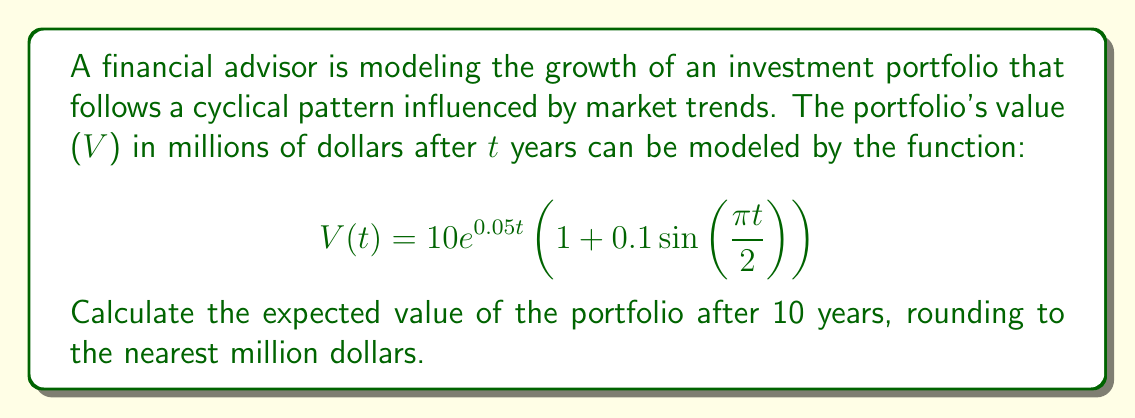Solve this math problem. Let's approach this step-by-step:

1) We're given the function:
   $$V(t) = 10e^{0.05t}(1 + 0.1\sin(\frac{\pi t}{2}))$$

2) We need to find V(10), so let's substitute t = 10:
   $$V(10) = 10e^{0.05(10)}(1 + 0.1\sin(\frac{\pi (10)}{2}))$$

3) Let's simplify the exponential part:
   $$e^{0.05(10)} = e^{0.5} \approx 1.6487$$

4) Now, let's simplify the sine part:
   $$\sin(\frac{\pi (10)}{2}) = \sin(5\pi) = 0$$

5) Substituting these values:
   $$V(10) = 10 * 1.6487 * (1 + 0.1 * 0)$$
   $$V(10) = 10 * 1.6487 * 1$$
   $$V(10) = 16.487$$

6) Rounding to the nearest million:
   $$V(10) \approx 16$$ million dollars
Answer: $16 million 